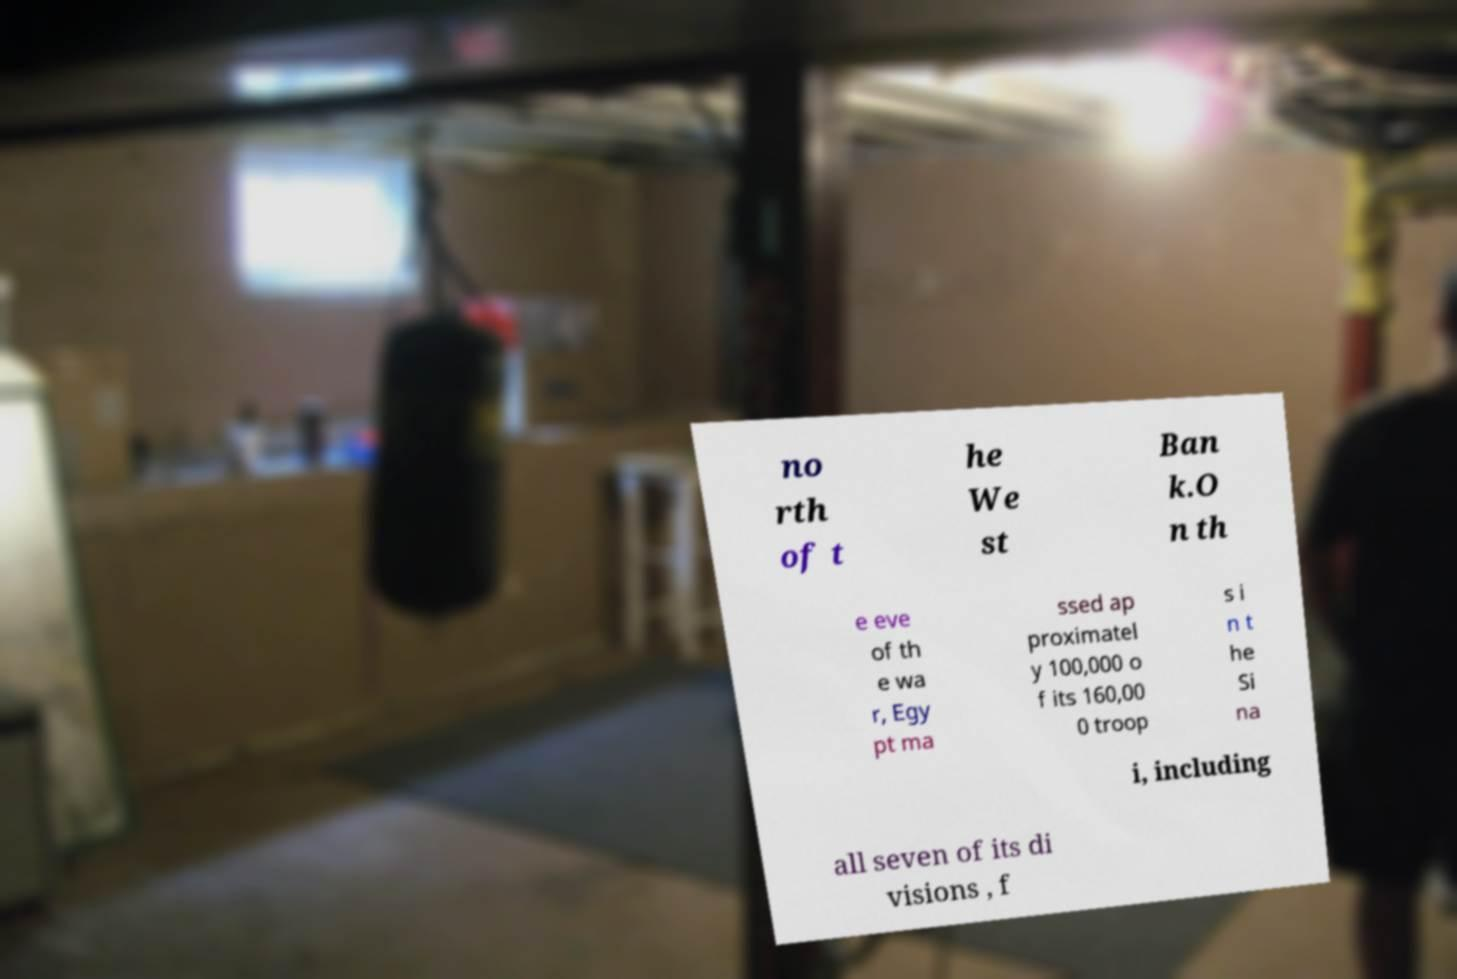Can you read and provide the text displayed in the image?This photo seems to have some interesting text. Can you extract and type it out for me? no rth of t he We st Ban k.O n th e eve of th e wa r, Egy pt ma ssed ap proximatel y 100,000 o f its 160,00 0 troop s i n t he Si na i, including all seven of its di visions , f 